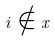<formula> <loc_0><loc_0><loc_500><loc_500>i \notin x</formula> 